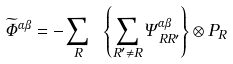<formula> <loc_0><loc_0><loc_500><loc_500>\widetilde { \Phi } ^ { \alpha \beta } = - \sum _ { R } \ \left \{ \sum _ { R ^ { \prime } \ne R } \Psi _ { R R ^ { \prime } } ^ { \alpha \beta } \right \} \otimes P _ { R }</formula> 